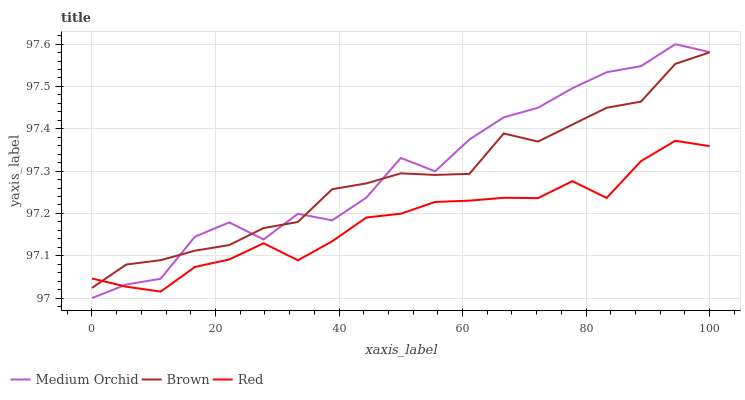Does Red have the minimum area under the curve?
Answer yes or no. Yes. Does Medium Orchid have the maximum area under the curve?
Answer yes or no. Yes. Does Medium Orchid have the minimum area under the curve?
Answer yes or no. No. Does Red have the maximum area under the curve?
Answer yes or no. No. Is Brown the smoothest?
Answer yes or no. Yes. Is Medium Orchid the roughest?
Answer yes or no. Yes. Is Red the smoothest?
Answer yes or no. No. Is Red the roughest?
Answer yes or no. No. Does Medium Orchid have the lowest value?
Answer yes or no. Yes. Does Red have the lowest value?
Answer yes or no. No. Does Medium Orchid have the highest value?
Answer yes or no. Yes. Does Red have the highest value?
Answer yes or no. No. Does Red intersect Medium Orchid?
Answer yes or no. Yes. Is Red less than Medium Orchid?
Answer yes or no. No. Is Red greater than Medium Orchid?
Answer yes or no. No. 